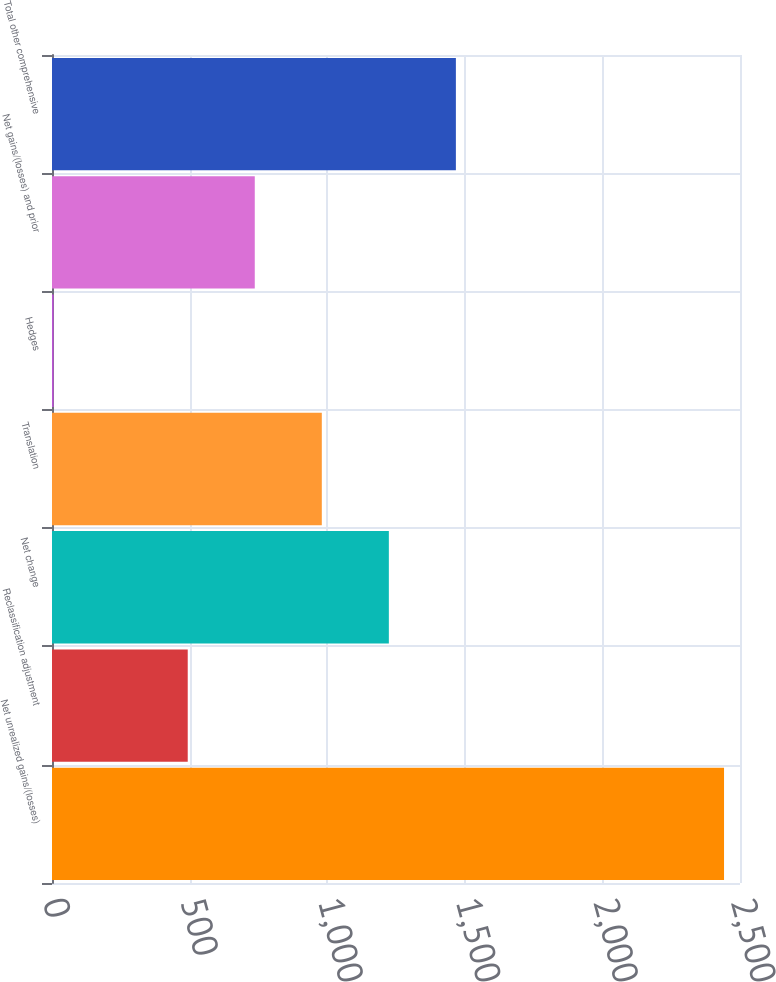<chart> <loc_0><loc_0><loc_500><loc_500><bar_chart><fcel>Net unrealized gains/(losses)<fcel>Reclassification adjustment<fcel>Net change<fcel>Translation<fcel>Hedges<fcel>Net gains/(losses) and prior<fcel>Total other comprehensive<nl><fcel>2442<fcel>493.2<fcel>1224<fcel>980.4<fcel>6<fcel>736.8<fcel>1467.6<nl></chart> 